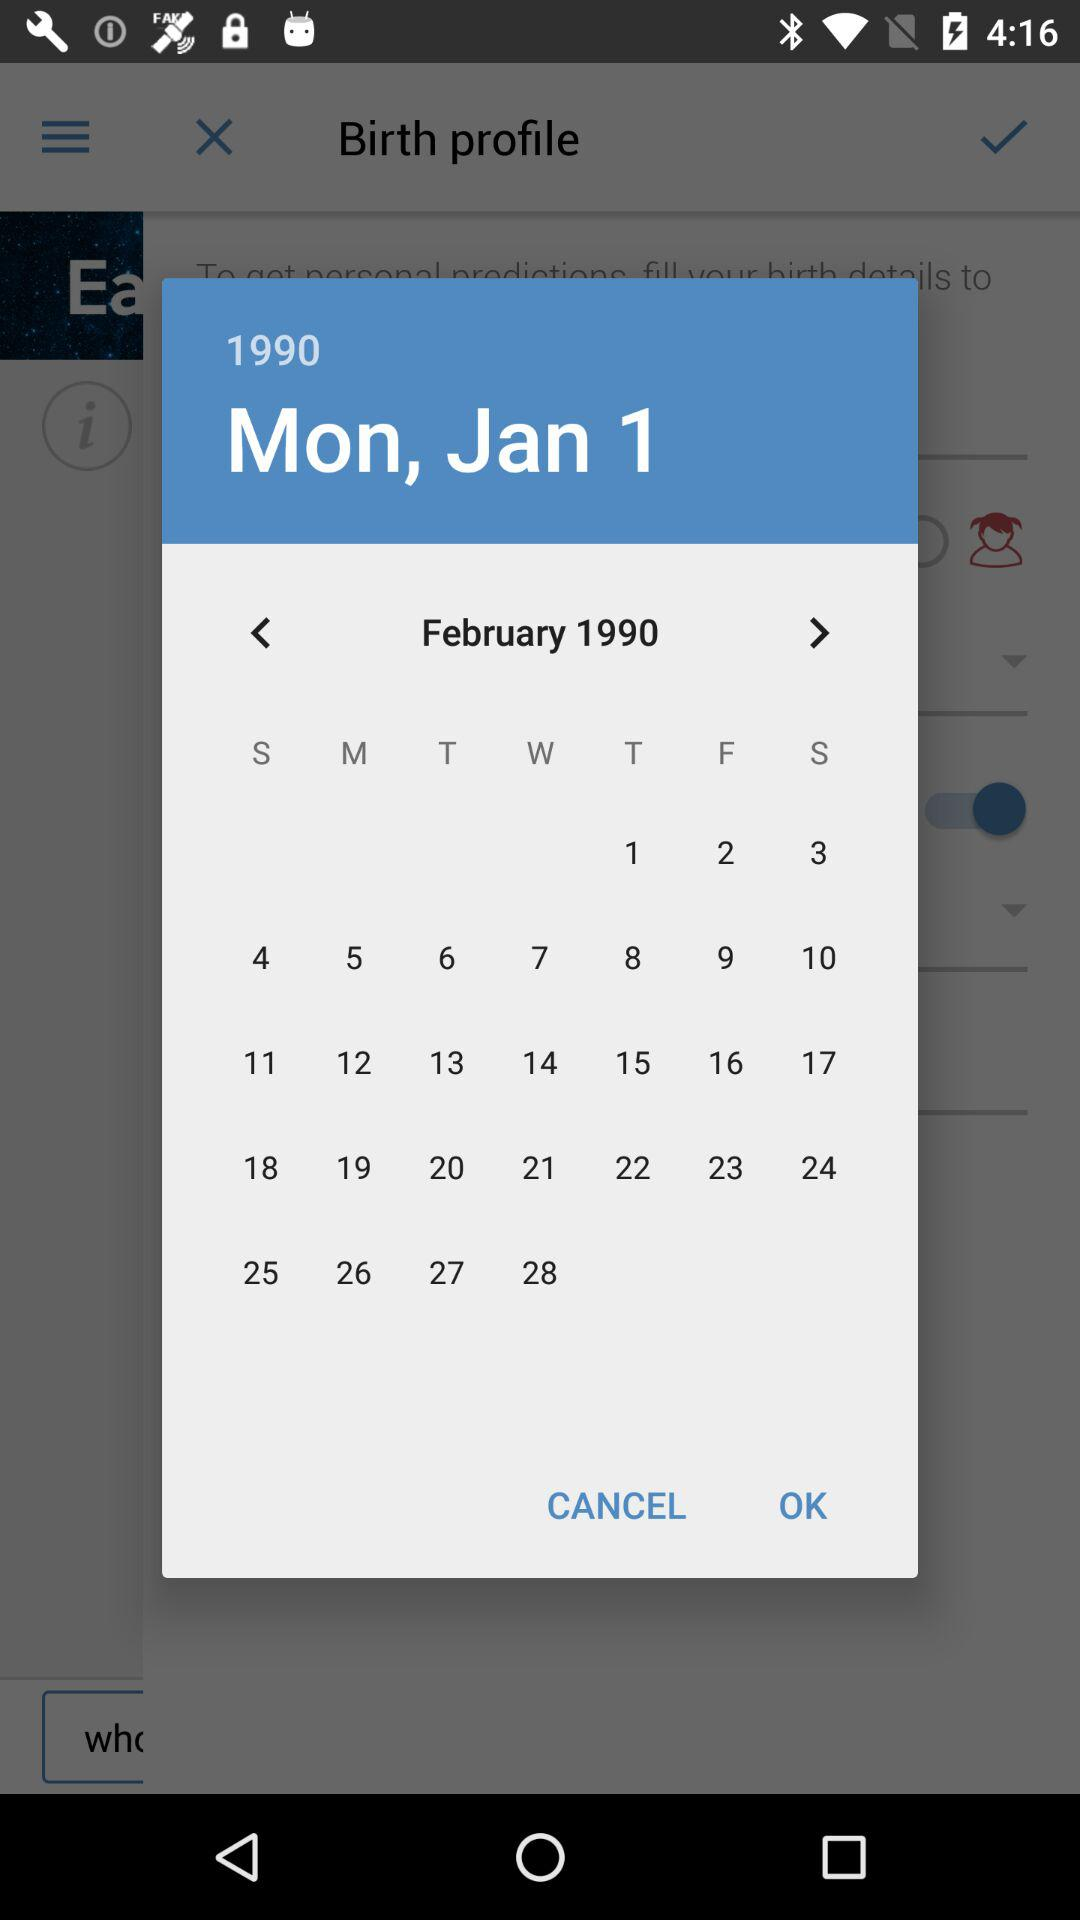What is the given date? The given date is Monday, January 1, 1990. 